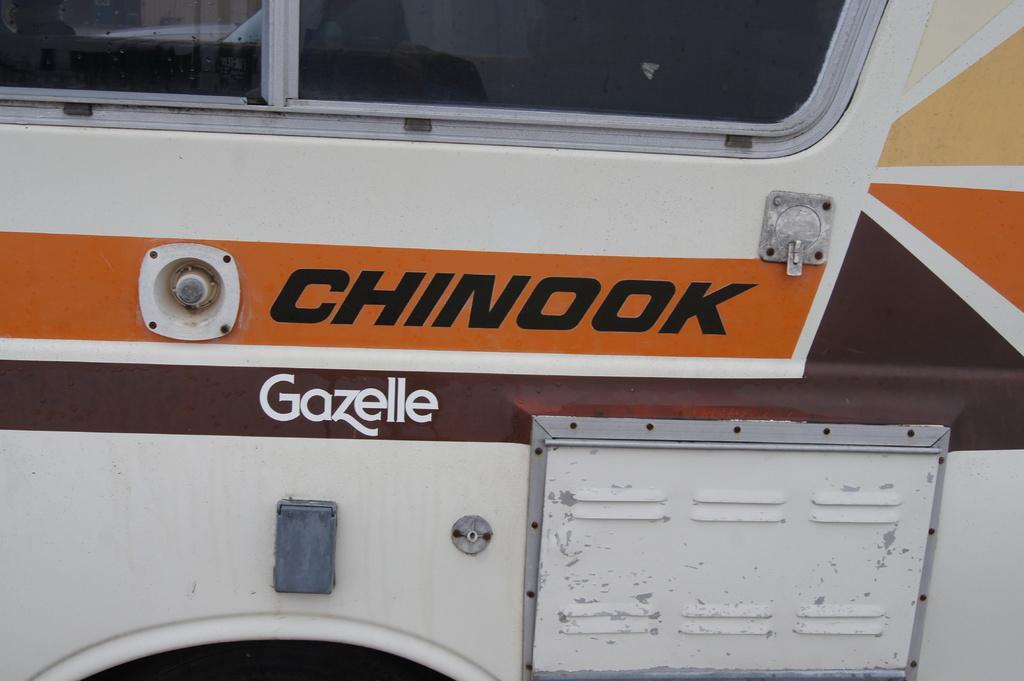Could you give a brief overview of what you see in this image? Here we can see a vehicle and there is a text written on it and this is a glass door. 